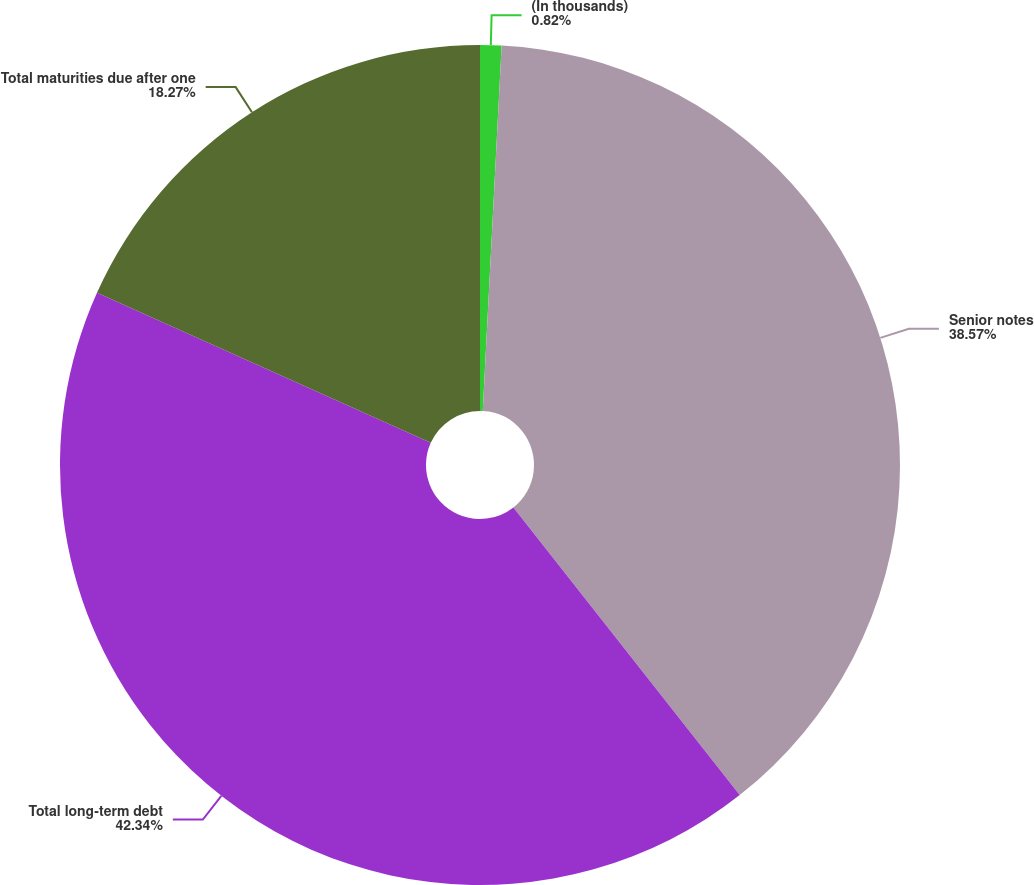<chart> <loc_0><loc_0><loc_500><loc_500><pie_chart><fcel>(In thousands)<fcel>Senior notes<fcel>Total long-term debt<fcel>Total maturities due after one<nl><fcel>0.82%<fcel>38.57%<fcel>42.34%<fcel>18.27%<nl></chart> 